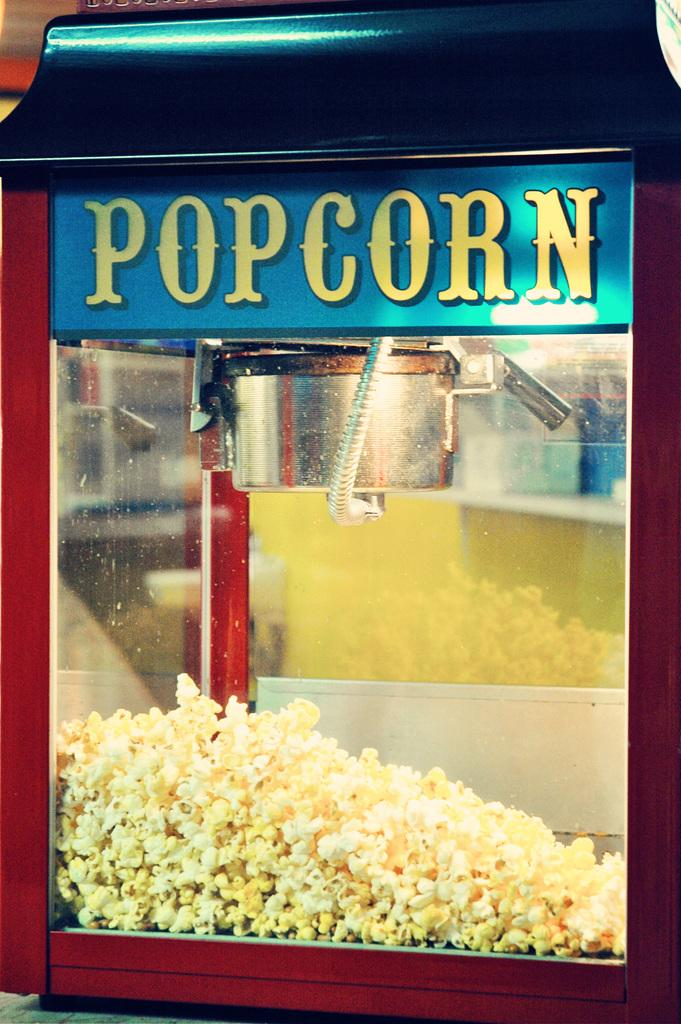<image>
Summarize the visual content of the image. a red trimmed glass box that says 'popcorn' on it in yellow 